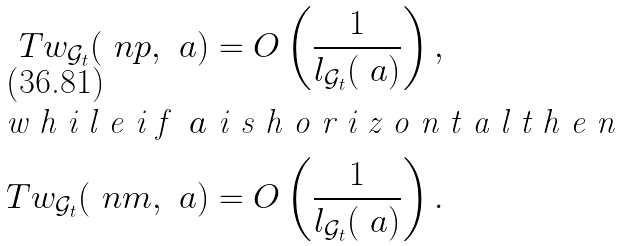Convert formula to latex. <formula><loc_0><loc_0><loc_500><loc_500>T w _ { \mathcal { G } _ { t } } ( \ n p , \ a ) & = O \left ( \frac { 1 } { l _ { \mathcal { G } _ { t } } ( \ a ) } \right ) , \\ \intertext { w h i l e i f $ \ a $ i s h o r i z o n t a l t h e n } T w _ { \mathcal { G } _ { t } } ( \ n m , \ a ) & = O \left ( \frac { 1 } { l _ { \mathcal { G } _ { t } } ( \ a ) } \right ) .</formula> 